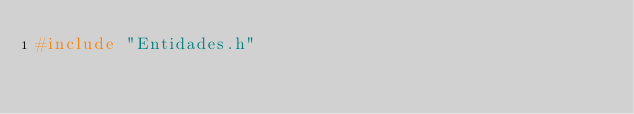<code> <loc_0><loc_0><loc_500><loc_500><_C++_>#include "Entidades.h"

</code> 